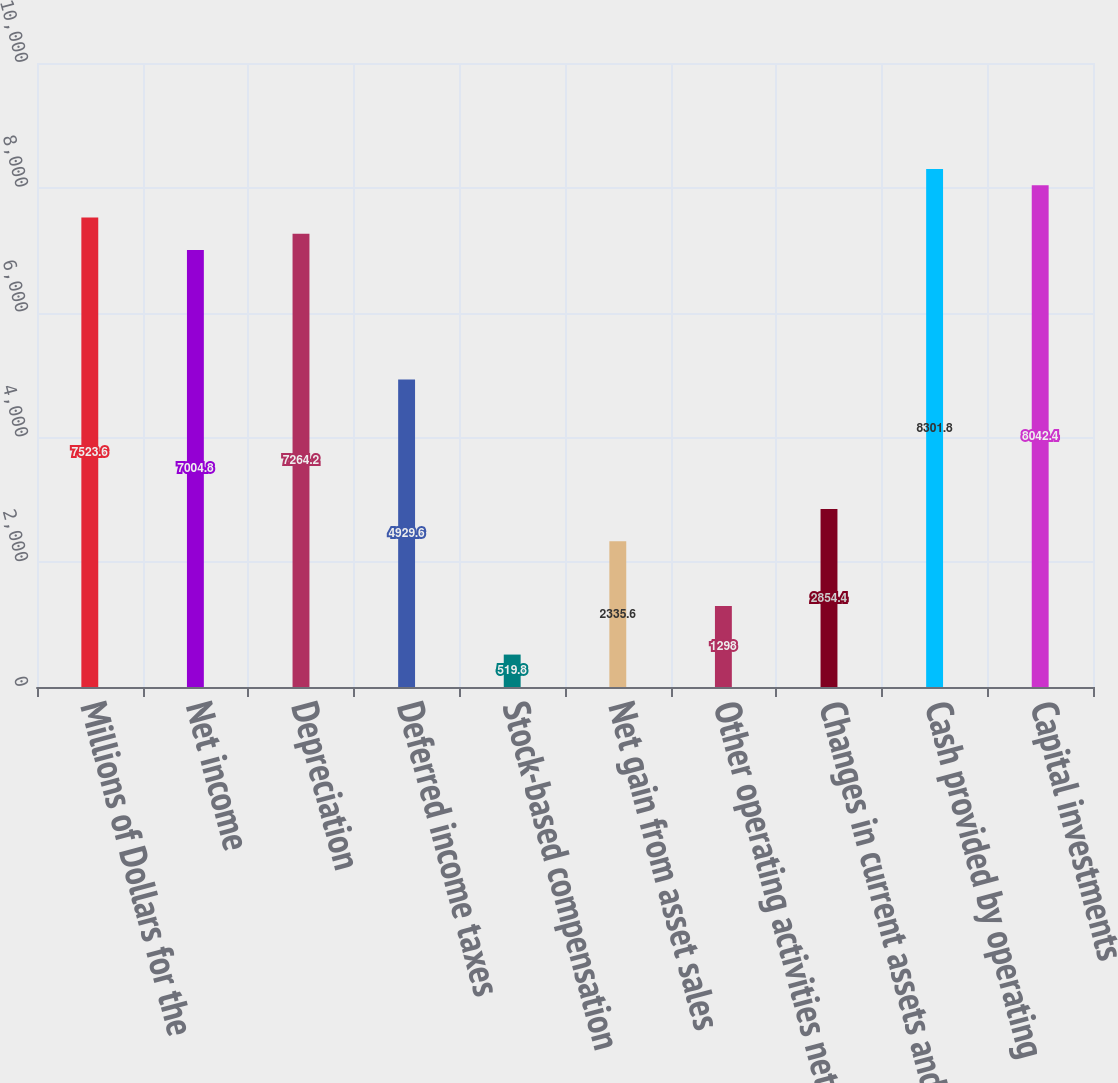Convert chart to OTSL. <chart><loc_0><loc_0><loc_500><loc_500><bar_chart><fcel>Millions of Dollars for the<fcel>Net income<fcel>Depreciation<fcel>Deferred income taxes<fcel>Stock-based compensation<fcel>Net gain from asset sales<fcel>Other operating activities net<fcel>Changes in current assets and<fcel>Cash provided by operating<fcel>Capital investments<nl><fcel>7523.6<fcel>7004.8<fcel>7264.2<fcel>4929.6<fcel>519.8<fcel>2335.6<fcel>1298<fcel>2854.4<fcel>8301.8<fcel>8042.4<nl></chart> 